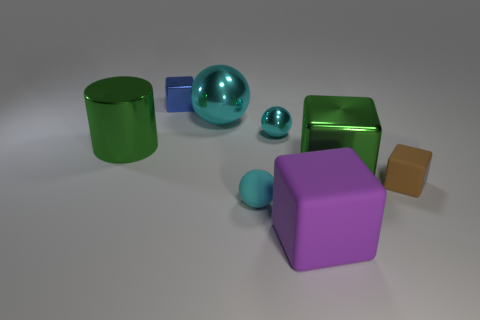How many cyan spheres must be subtracted to get 1 cyan spheres? 2 Subtract all red cubes. Subtract all green spheres. How many cubes are left? 4 Add 1 purple matte objects. How many objects exist? 9 Subtract all spheres. How many objects are left? 5 Subtract 0 red blocks. How many objects are left? 8 Subtract all small green rubber blocks. Subtract all large cyan objects. How many objects are left? 7 Add 2 blue blocks. How many blue blocks are left? 3 Add 6 cyan shiny cylinders. How many cyan shiny cylinders exist? 6 